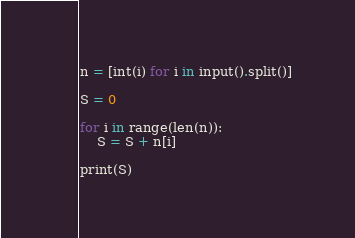Convert code to text. <code><loc_0><loc_0><loc_500><loc_500><_Python_>
n = [int(i) for i in input().split()]

S = 0

for i in range(len(n)):
    S = S + n[i]

print(S)

</code> 